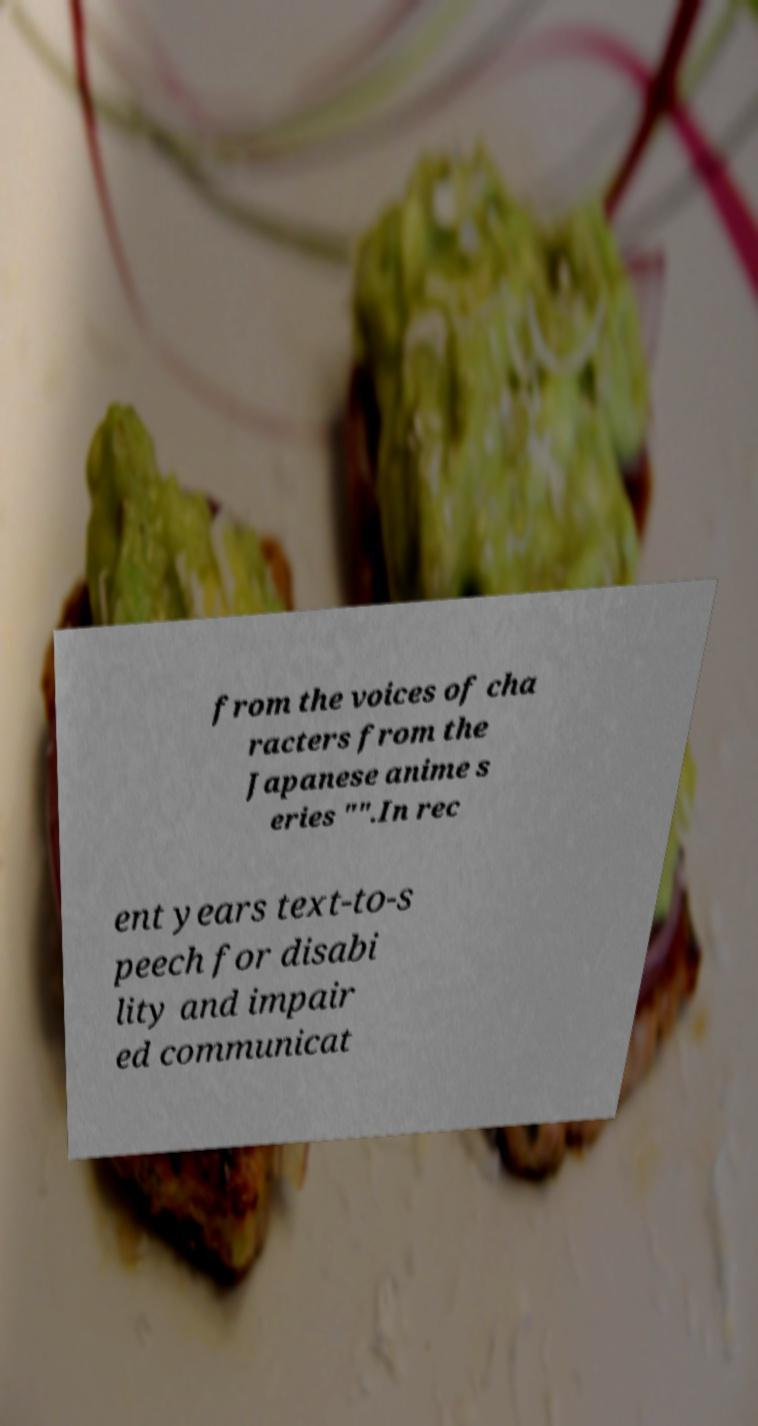I need the written content from this picture converted into text. Can you do that? from the voices of cha racters from the Japanese anime s eries "".In rec ent years text-to-s peech for disabi lity and impair ed communicat 